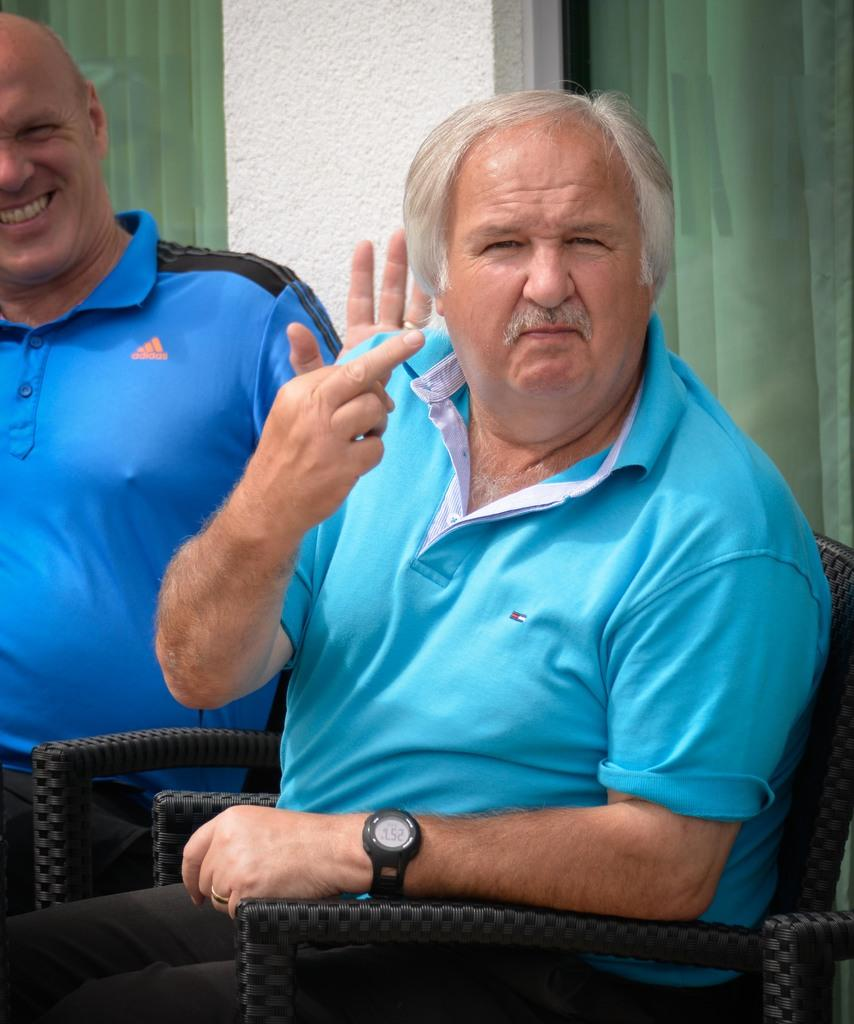How many people are in the image? There are two men in the image. What are the men doing in the image? The men are posing for a photo. What are the men sitting on in the image? The men are sitting on a black chair. What can be seen behind the men in the image? There are two windows behind the men, and there is a wall between the windows. What type of line can be seen connecting the two men in the image? There is no line connecting the two men in the image. What kind of flesh can be seen on the men's faces in the image? There is no need to describe the men's flesh, as the focus should be on the subjects and objects in the image. 